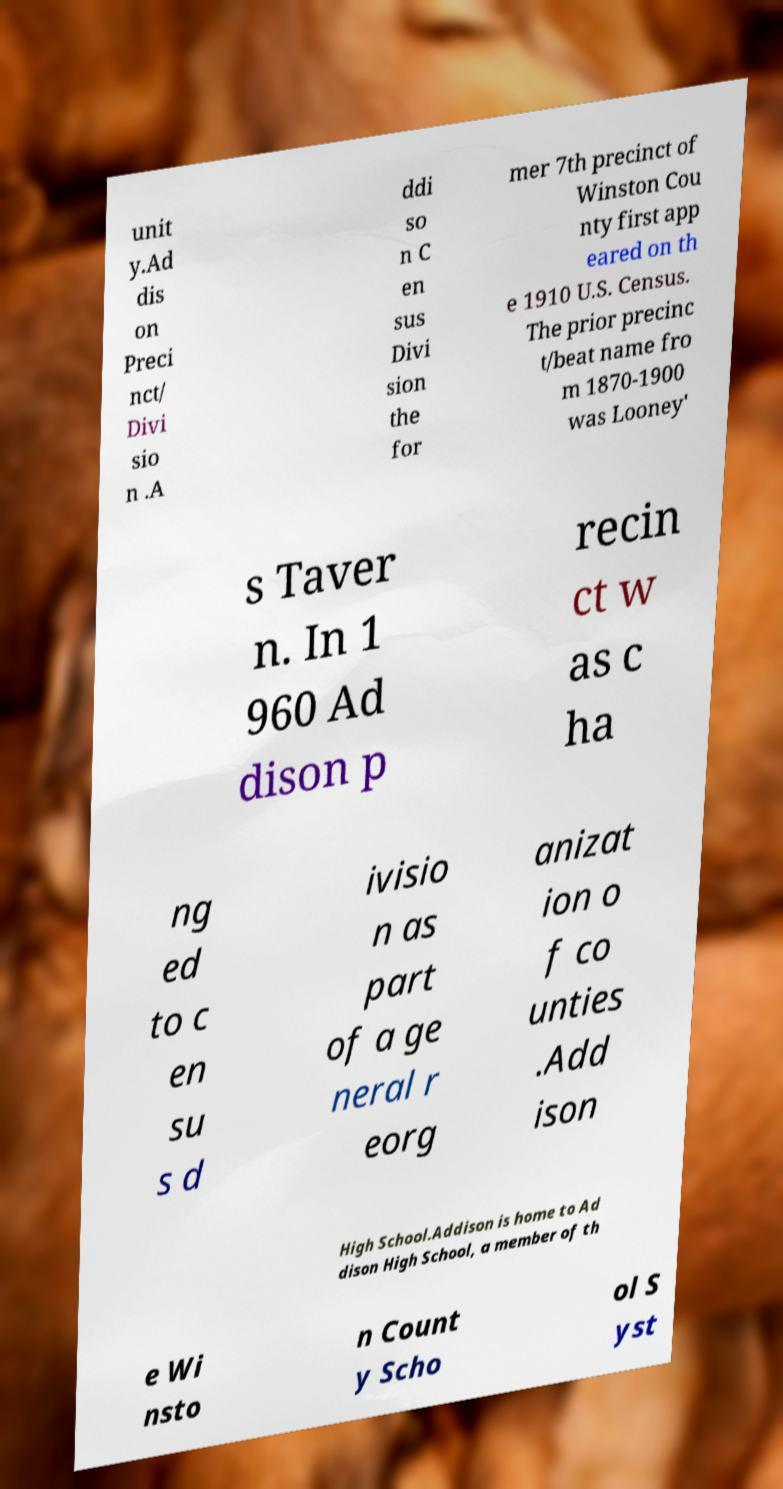Please identify and transcribe the text found in this image. unit y.Ad dis on Preci nct/ Divi sio n .A ddi so n C en sus Divi sion the for mer 7th precinct of Winston Cou nty first app eared on th e 1910 U.S. Census. The prior precinc t/beat name fro m 1870-1900 was Looney' s Taver n. In 1 960 Ad dison p recin ct w as c ha ng ed to c en su s d ivisio n as part of a ge neral r eorg anizat ion o f co unties .Add ison High School.Addison is home to Ad dison High School, a member of th e Wi nsto n Count y Scho ol S yst 